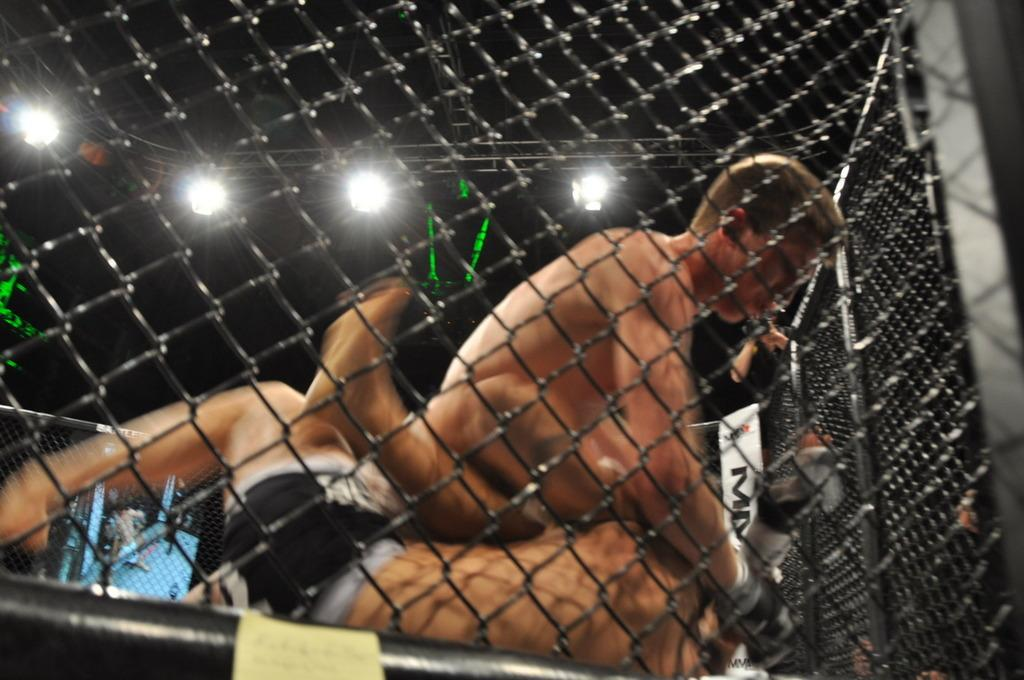What type of barrier is present in the foreground of the image? There is a net fencing in the foreground of the image. What are the two men in the image doing? The two men are fighting in the image. What can be seen in the background of the image? There are lights visible in the background of the image. How would you describe the lighting conditions in the image? The background appears to be dark. How many jellyfish can be seen swimming in the image? There are no jellyfish present in the image. What type of grape is being used as a weapon by one of the men in the image? There is no grape present in the image, and neither man is using a grape as a weapon. 